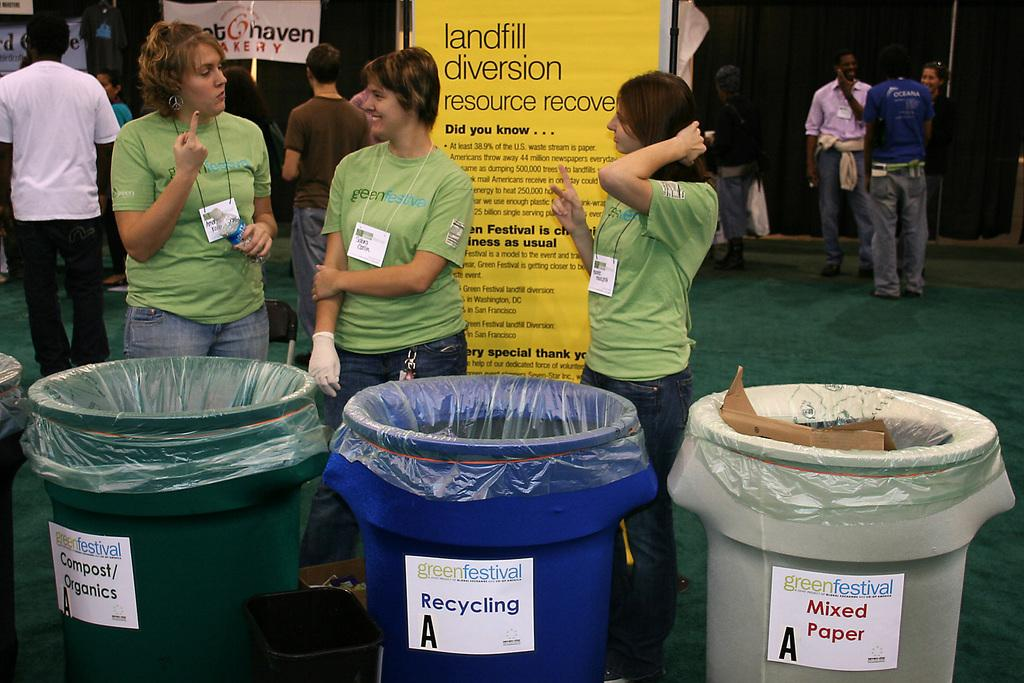<image>
Share a concise interpretation of the image provided. Three different kinds of recycling bins are collection for the green festival. 